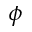Convert formula to latex. <formula><loc_0><loc_0><loc_500><loc_500>\phi</formula> 